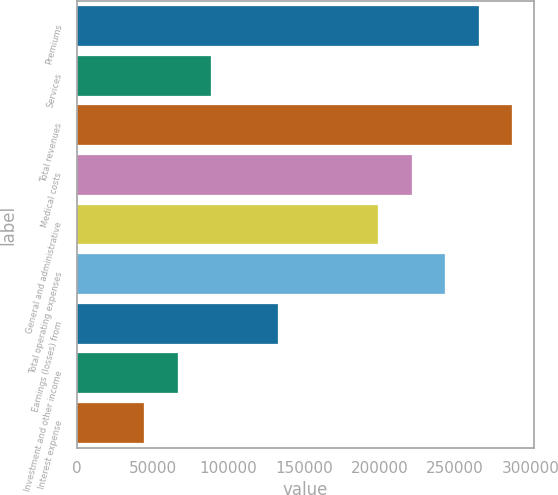Convert chart to OTSL. <chart><loc_0><loc_0><loc_500><loc_500><bar_chart><fcel>Premiums<fcel>Services<fcel>Total revenues<fcel>Medical costs<fcel>General and administrative<fcel>Total operating expenses<fcel>Earnings (losses) from<fcel>Investment and other income<fcel>Interest expense<nl><fcel>265620<fcel>88540.4<fcel>287755<fcel>221350<fcel>199215<fcel>243485<fcel>132810<fcel>66405.5<fcel>44270.6<nl></chart> 